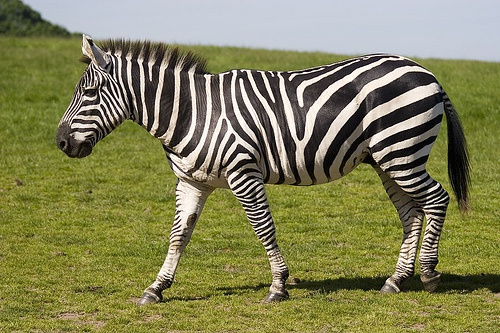Describe the objects in this image and their specific colors. I can see a zebra in darkgreen, black, ivory, and gray tones in this image. 